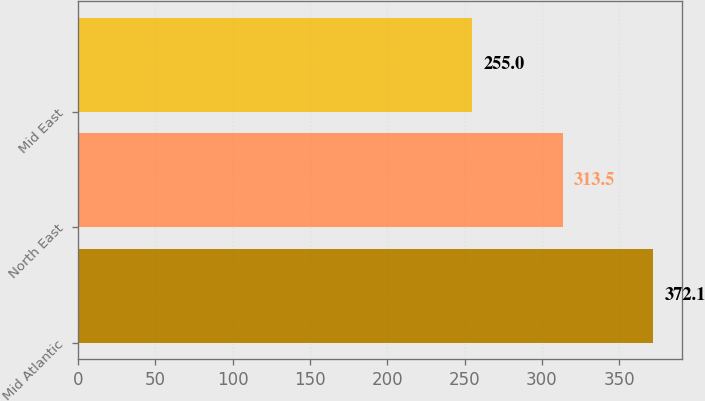Convert chart to OTSL. <chart><loc_0><loc_0><loc_500><loc_500><bar_chart><fcel>Mid Atlantic<fcel>North East<fcel>Mid East<nl><fcel>372.1<fcel>313.5<fcel>255<nl></chart> 